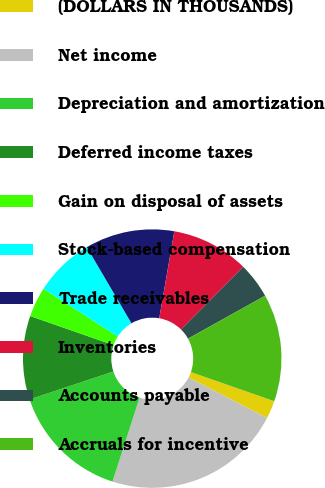<chart> <loc_0><loc_0><loc_500><loc_500><pie_chart><fcel>(DOLLARS IN THOUSANDS)<fcel>Net income<fcel>Depreciation and amortization<fcel>Deferred income taxes<fcel>Gain on disposal of assets<fcel>Stock-based compensation<fcel>Trade receivables<fcel>Inventories<fcel>Accounts payable<fcel>Accruals for incentive<nl><fcel>2.25%<fcel>22.38%<fcel>14.92%<fcel>10.45%<fcel>3.74%<fcel>7.47%<fcel>11.19%<fcel>9.7%<fcel>4.48%<fcel>13.43%<nl></chart> 